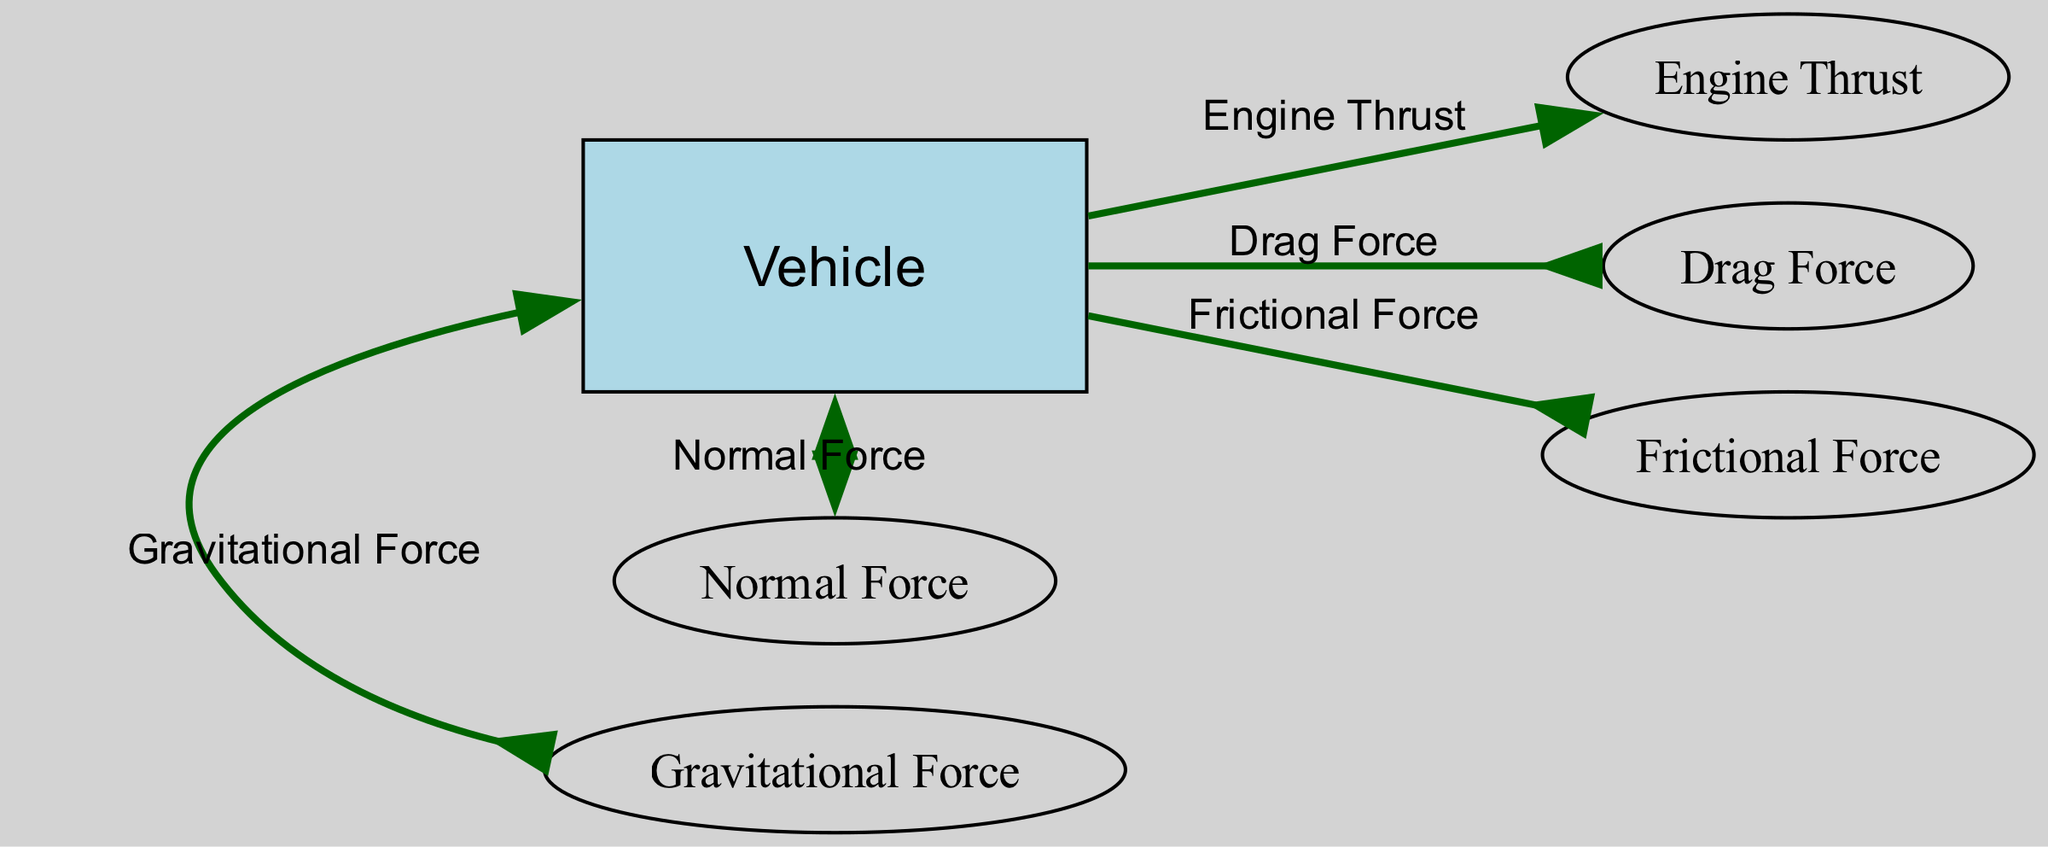What is the central entity in this diagram? The central entity depicted in the diagram is labeled as "Vehicle," which represents the car experiencing acceleration. It serves as the main focus around which the forces act.
Answer: Vehicle How many arrows are pointing to the left? There are two arrows pointing to the left in the diagram: one for "Drag Force" and one for "Frictional Force," which both oppose the vehicle's motion.
Answer: 2 What force acts upwards on the vehicle? The upward force acting on the vehicle is the "Normal Force," which is exerted by the road to balance the weight of the vehicle.
Answer: Normal Force What type of force opposes the vehicle's motion due to air resistance? The force that opposes the vehicle's motion due to air resistance is called "Drag Force," which is specifically indicated by one of the arrows pointing to the left.
Answer: Drag Force Which two forces are acting downwards and upwards on the vehicle? The "Gravitational Force" acts downwards, pulling the vehicle towards the Earth, while the "Normal Force" acts upwards, balancing the weight of the vehicle against gravity.
Answer: Gravitational Force and Normal Force Which force is generated by the vehicle's engine? The force generated by the vehicle's engine, which is responsible for accelerating the vehicle forward, is known as "Engine Thrust." This force is represented by the arrow pointing to the right.
Answer: Engine Thrust What is the relationship between the "Frictional Force" and the "Engine Thrust"? The "Frictional Force" opposes the vehicle's motion just like the "Drag Force," meaning both oppose the forward acceleration caused by the "Engine Thrust," leading to a net force that determines the vehicle's acceleration.
Answer: Opposing forces What is the direction of the Drag Force in relation to the Vehicle? The Drag Force is directed to the left relative to the Vehicle, indicating that it opposes the vehicle's forward motion caused by the "Engine Thrust."
Answer: Left 